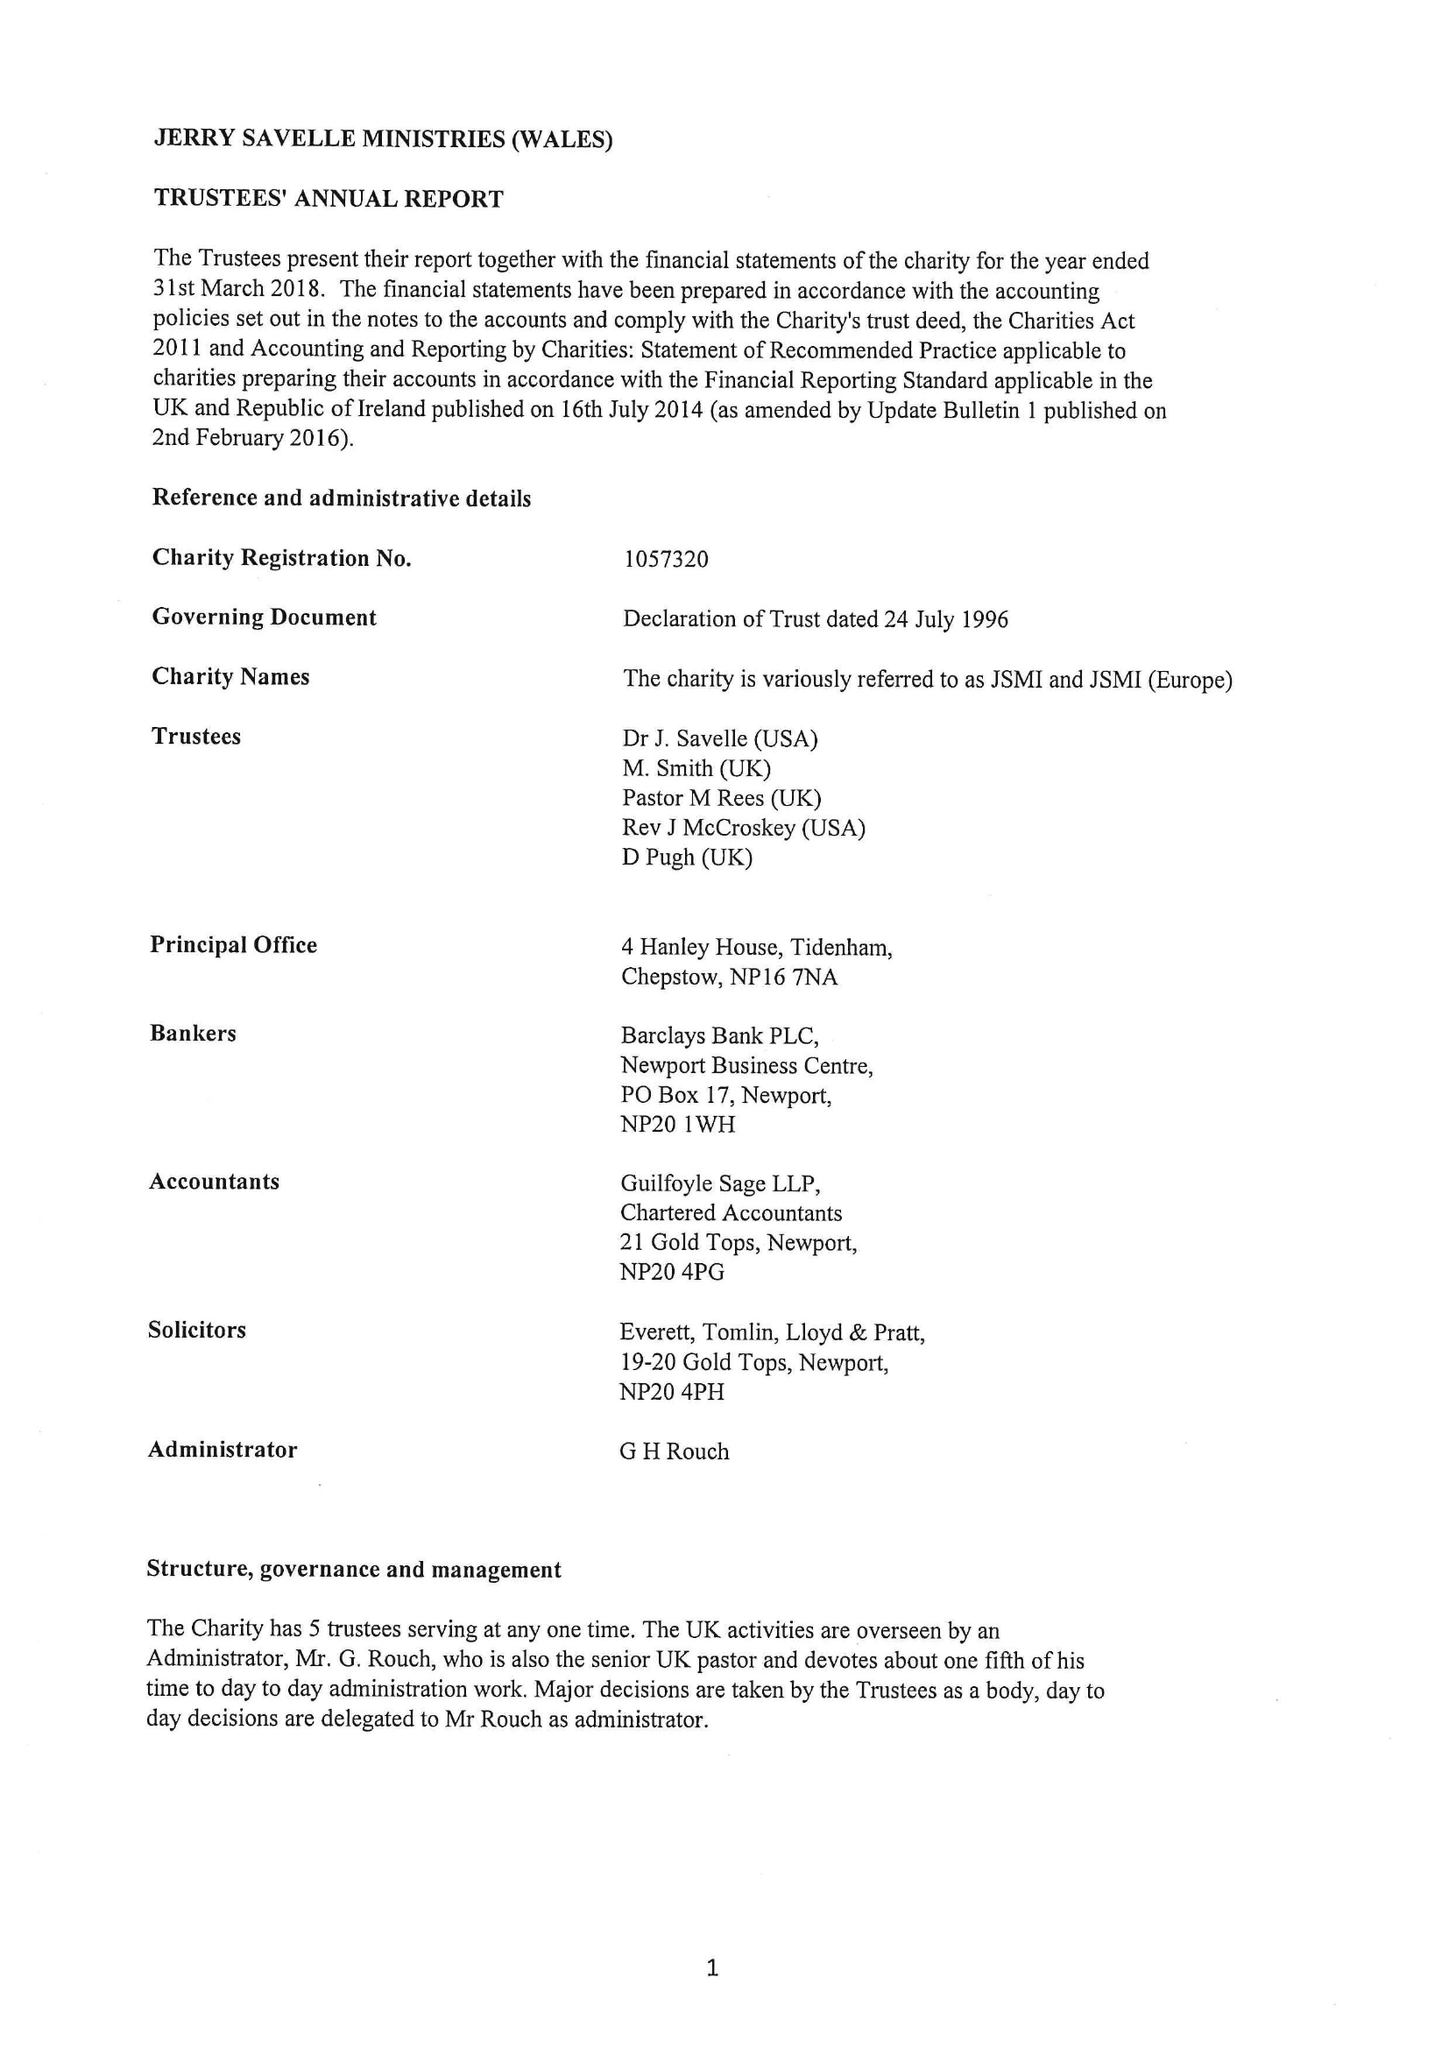What is the value for the charity_name?
Answer the question using a single word or phrase. Jerry Savelle Ministries (Wales) 